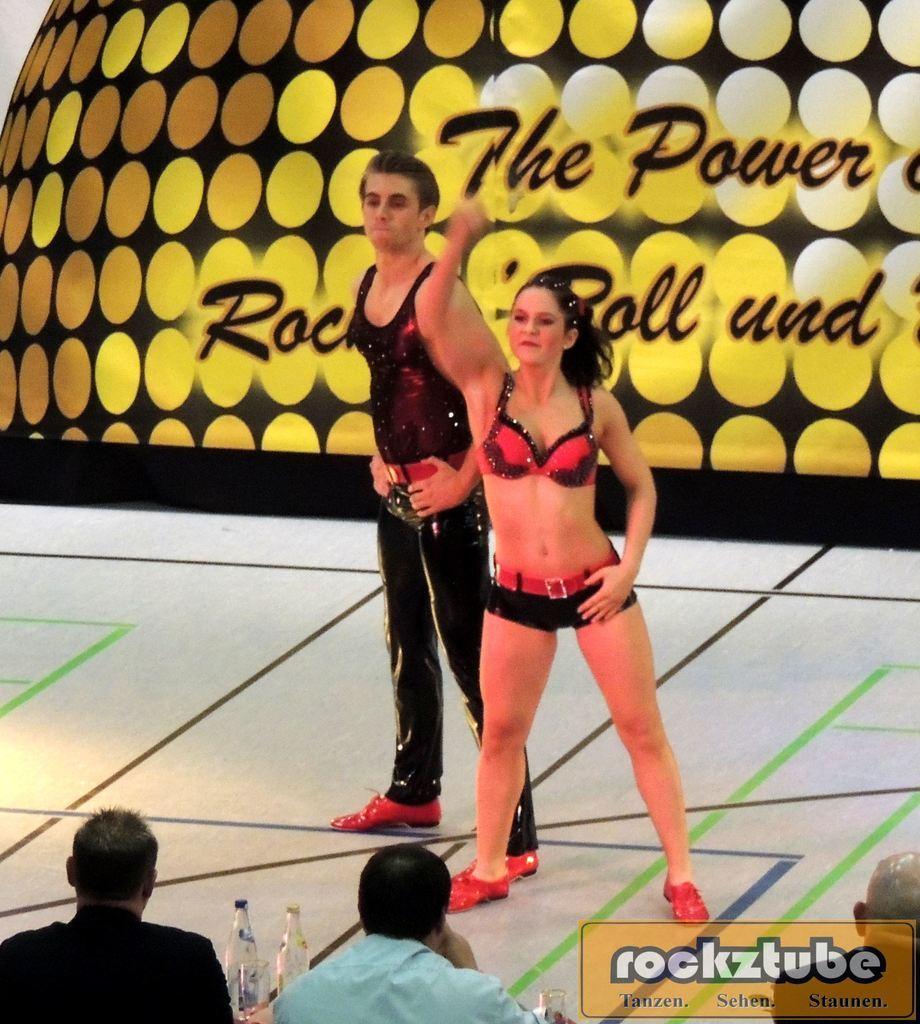How would you summarize this image in a sentence or two? In the center of the image, we can see a man and a lady standing on the stage and in the background, there is a board and we can see some text. At the bottom, there are some other people, some text and we can see bottles and glasses. 